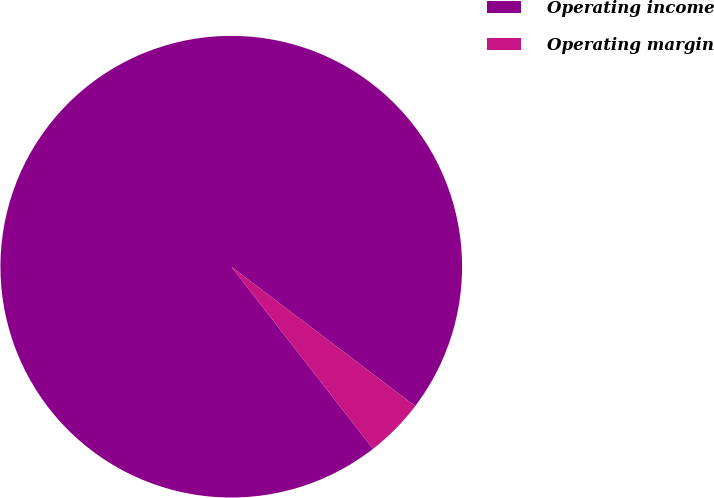Convert chart. <chart><loc_0><loc_0><loc_500><loc_500><pie_chart><fcel>Operating income<fcel>Operating margin<nl><fcel>95.85%<fcel>4.15%<nl></chart> 